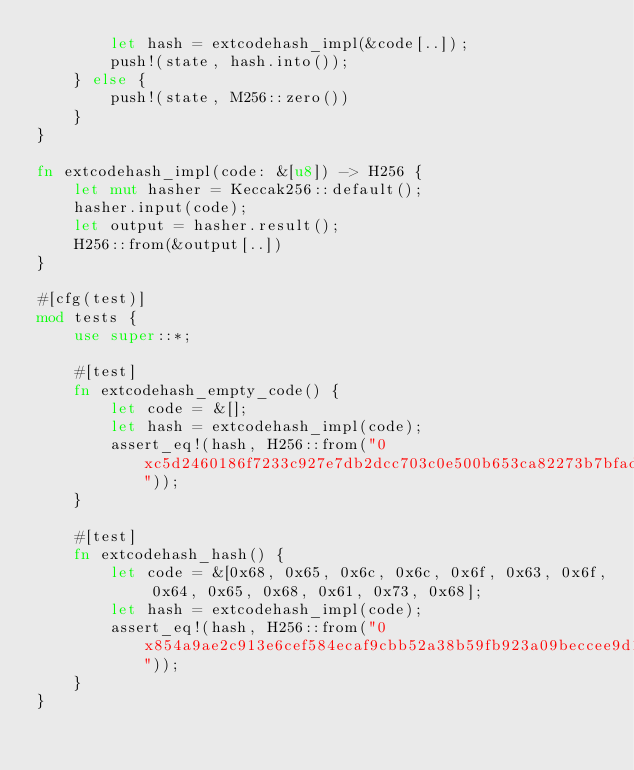<code> <loc_0><loc_0><loc_500><loc_500><_Rust_>        let hash = extcodehash_impl(&code[..]);
        push!(state, hash.into());
    } else {
        push!(state, M256::zero())
    }
}

fn extcodehash_impl(code: &[u8]) -> H256 {
    let mut hasher = Keccak256::default();
    hasher.input(code);
    let output = hasher.result();
    H256::from(&output[..])
}

#[cfg(test)]
mod tests {
    use super::*;

    #[test]
    fn extcodehash_empty_code() {
        let code = &[];
        let hash = extcodehash_impl(code);
        assert_eq!(hash, H256::from("0xc5d2460186f7233c927e7db2dcc703c0e500b653ca82273b7bfad8045d85a470"));
    }

    #[test]
    fn extcodehash_hash() {
        let code = &[0x68, 0x65, 0x6c, 0x6c, 0x6f, 0x63, 0x6f, 0x64, 0x65, 0x68, 0x61, 0x73, 0x68];
        let hash = extcodehash_impl(code);
        assert_eq!(hash, H256::from("0x854a9ae2c913e6cef584ecaf9cbb52a38b59fb923a09beccee9d17c17d15cf7a"));
    }
}
</code> 